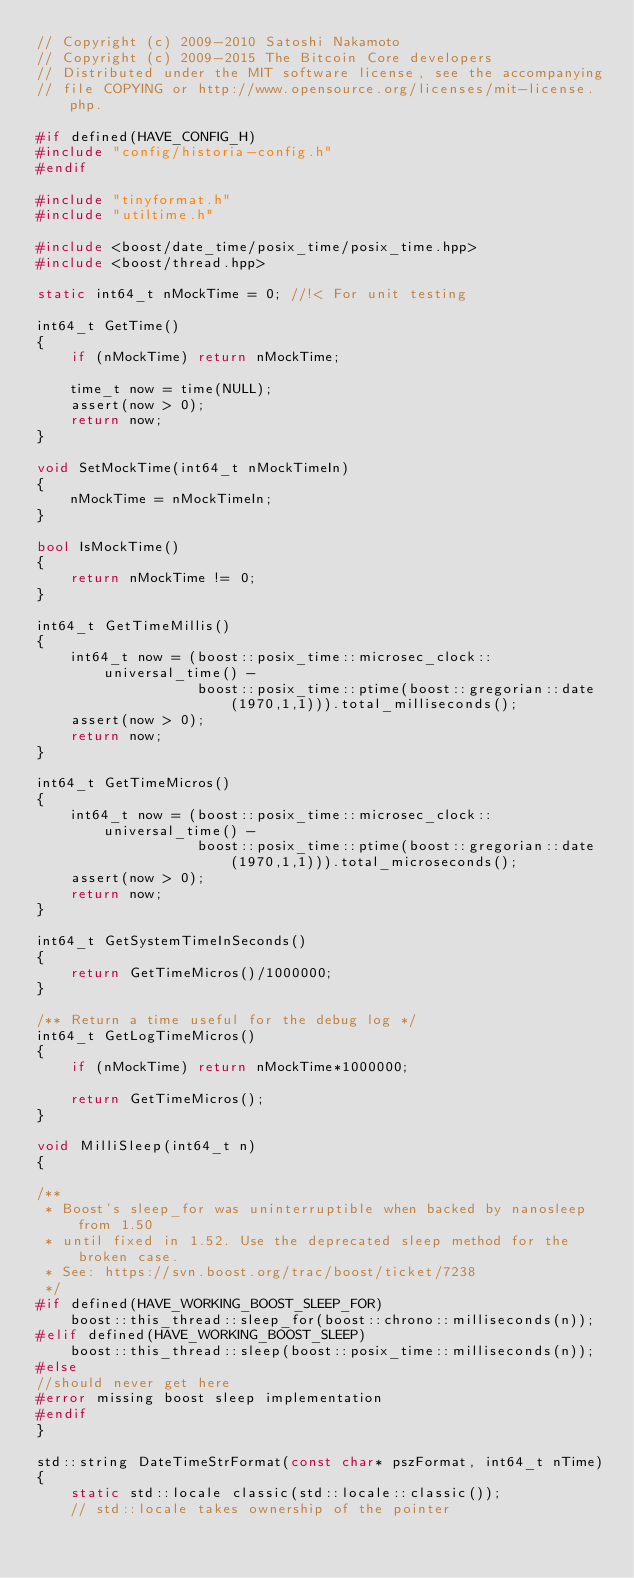Convert code to text. <code><loc_0><loc_0><loc_500><loc_500><_C++_>// Copyright (c) 2009-2010 Satoshi Nakamoto
// Copyright (c) 2009-2015 The Bitcoin Core developers
// Distributed under the MIT software license, see the accompanying
// file COPYING or http://www.opensource.org/licenses/mit-license.php.

#if defined(HAVE_CONFIG_H)
#include "config/historia-config.h"
#endif

#include "tinyformat.h"
#include "utiltime.h"

#include <boost/date_time/posix_time/posix_time.hpp>
#include <boost/thread.hpp>

static int64_t nMockTime = 0; //!< For unit testing

int64_t GetTime()
{
    if (nMockTime) return nMockTime;

    time_t now = time(NULL);
    assert(now > 0);
    return now;
}

void SetMockTime(int64_t nMockTimeIn)
{
    nMockTime = nMockTimeIn;
}

bool IsMockTime()
{
    return nMockTime != 0;
}

int64_t GetTimeMillis()
{
    int64_t now = (boost::posix_time::microsec_clock::universal_time() -
                   boost::posix_time::ptime(boost::gregorian::date(1970,1,1))).total_milliseconds();
    assert(now > 0);
    return now;
}

int64_t GetTimeMicros()
{
    int64_t now = (boost::posix_time::microsec_clock::universal_time() -
                   boost::posix_time::ptime(boost::gregorian::date(1970,1,1))).total_microseconds();
    assert(now > 0);
    return now;
}

int64_t GetSystemTimeInSeconds()
{
    return GetTimeMicros()/1000000;
}

/** Return a time useful for the debug log */
int64_t GetLogTimeMicros()
{
    if (nMockTime) return nMockTime*1000000;

    return GetTimeMicros();
}

void MilliSleep(int64_t n)
{

/**
 * Boost's sleep_for was uninterruptible when backed by nanosleep from 1.50
 * until fixed in 1.52. Use the deprecated sleep method for the broken case.
 * See: https://svn.boost.org/trac/boost/ticket/7238
 */
#if defined(HAVE_WORKING_BOOST_SLEEP_FOR)
    boost::this_thread::sleep_for(boost::chrono::milliseconds(n));
#elif defined(HAVE_WORKING_BOOST_SLEEP)
    boost::this_thread::sleep(boost::posix_time::milliseconds(n));
#else
//should never get here
#error missing boost sleep implementation
#endif
}

std::string DateTimeStrFormat(const char* pszFormat, int64_t nTime)
{
    static std::locale classic(std::locale::classic());
    // std::locale takes ownership of the pointer</code> 